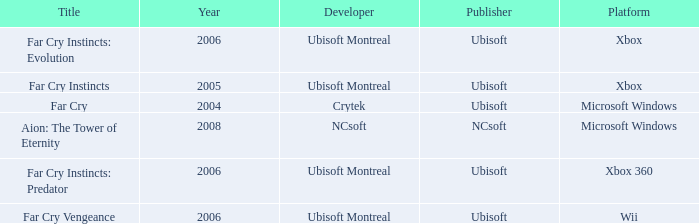Which developer has xbox 360 as the platform? Ubisoft Montreal. 